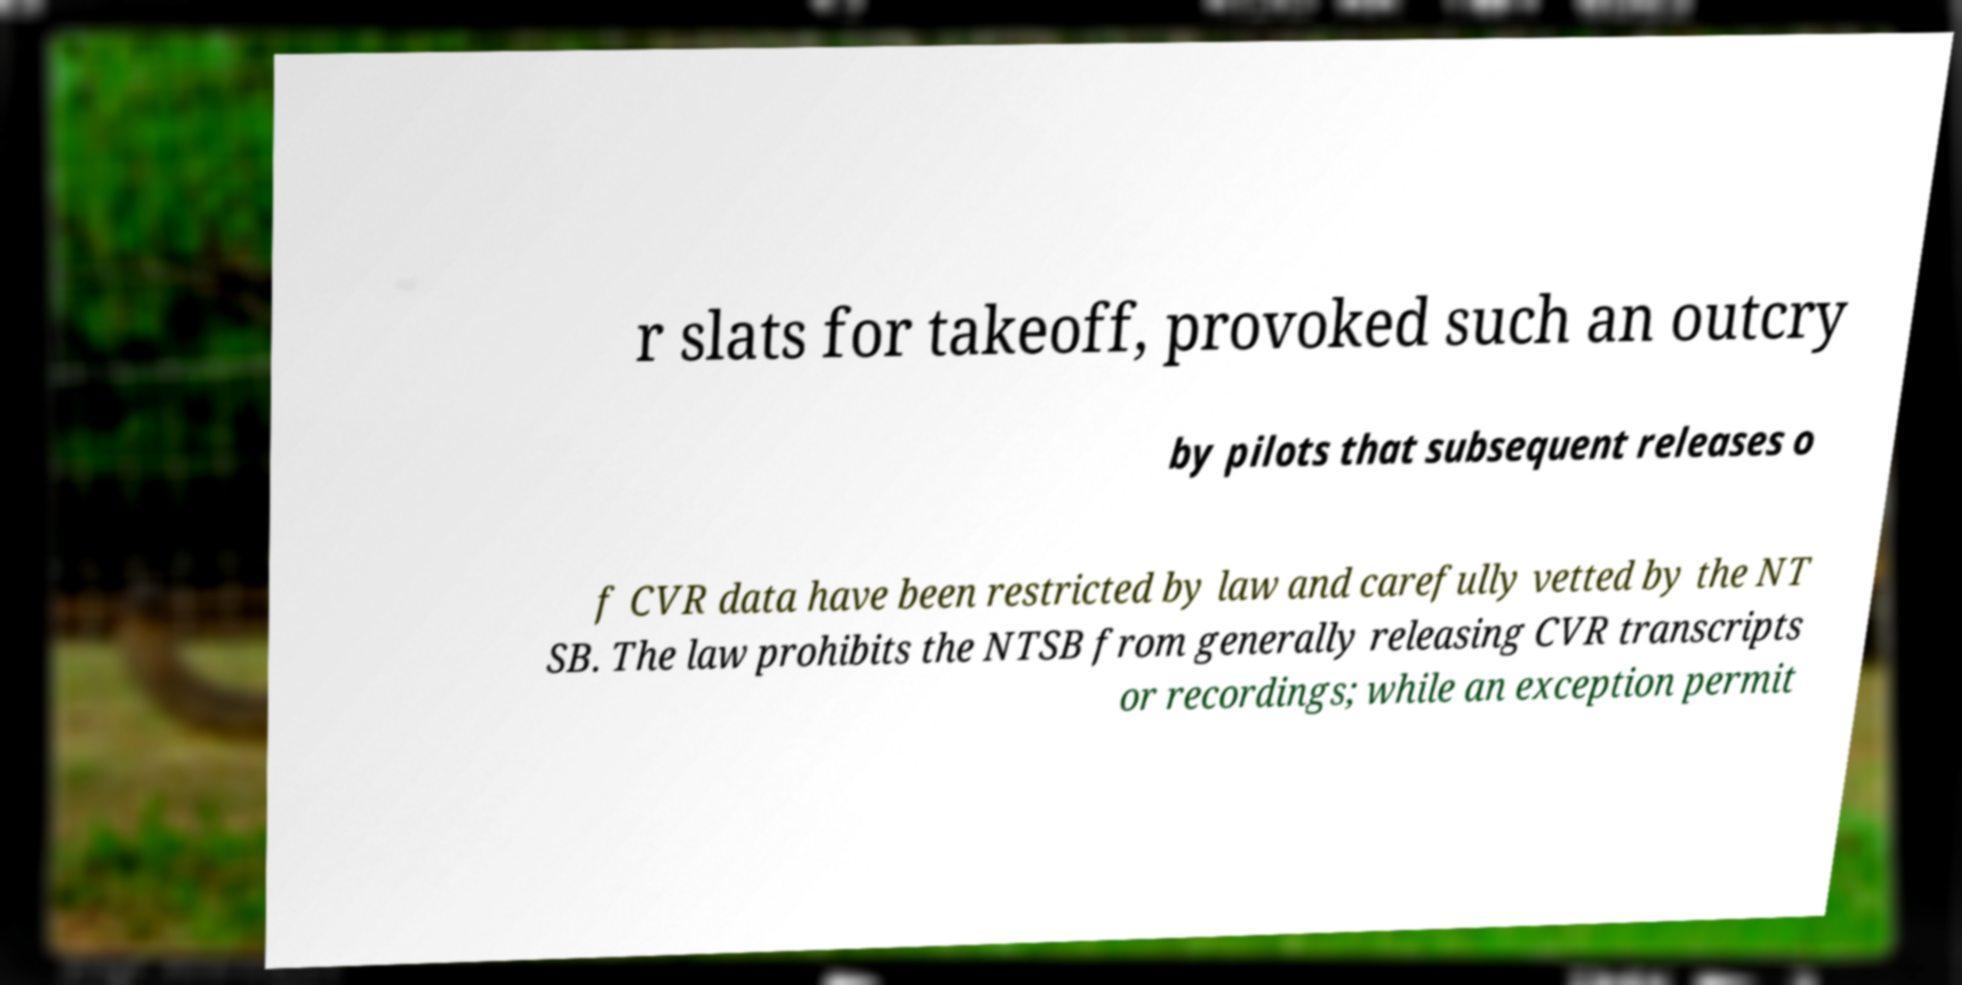Could you assist in decoding the text presented in this image and type it out clearly? r slats for takeoff, provoked such an outcry by pilots that subsequent releases o f CVR data have been restricted by law and carefully vetted by the NT SB. The law prohibits the NTSB from generally releasing CVR transcripts or recordings; while an exception permit 